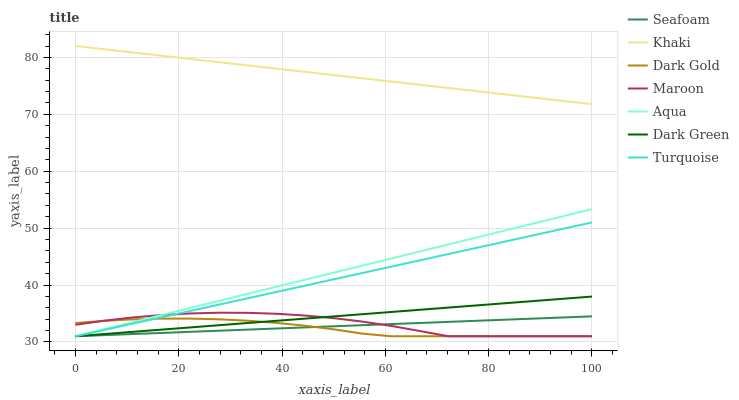Does Dark Gold have the minimum area under the curve?
Answer yes or no. Yes. Does Khaki have the maximum area under the curve?
Answer yes or no. Yes. Does Khaki have the minimum area under the curve?
Answer yes or no. No. Does Dark Gold have the maximum area under the curve?
Answer yes or no. No. Is Dark Green the smoothest?
Answer yes or no. Yes. Is Maroon the roughest?
Answer yes or no. Yes. Is Khaki the smoothest?
Answer yes or no. No. Is Khaki the roughest?
Answer yes or no. No. Does Khaki have the lowest value?
Answer yes or no. No. Does Dark Gold have the highest value?
Answer yes or no. No. Is Maroon less than Khaki?
Answer yes or no. Yes. Is Khaki greater than Seafoam?
Answer yes or no. Yes. Does Maroon intersect Khaki?
Answer yes or no. No. 